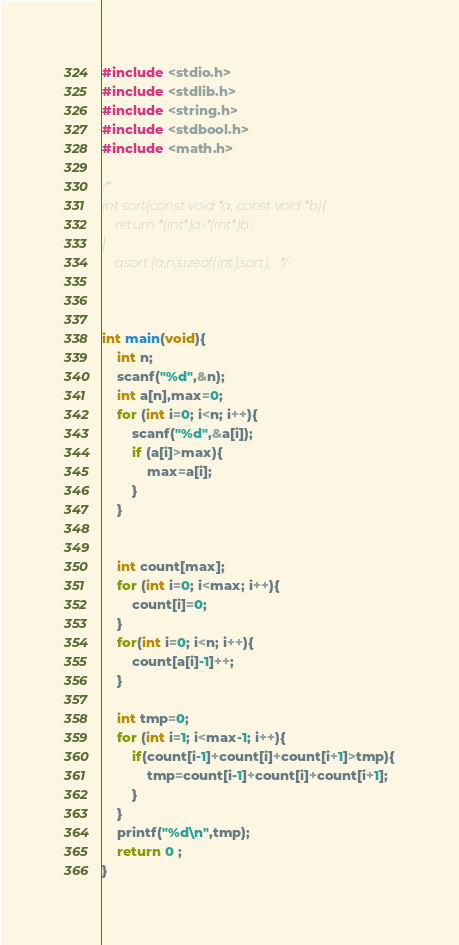<code> <loc_0><loc_0><loc_500><loc_500><_C_>#include <stdio.h>
#include <stdlib.h>
#include <string.h>
#include <stdbool.h>
#include <math.h>

/*
int sort(const void *a, const void *b){
    return *(int*)a-*(int*)b ;
}
    qsort (a,n,sizeof(int),sort);   */



int main(void){
    int n;
    scanf("%d",&n);
    int a[n],max=0;
    for (int i=0; i<n; i++){
        scanf("%d",&a[i]);
        if (a[i]>max){
            max=a[i];
        }
    }

    
    int count[max];
    for (int i=0; i<max; i++){
        count[i]=0;
    }
    for(int i=0; i<n; i++){
        count[a[i]-1]++;
    }
     
    int tmp=0;
    for (int i=1; i<max-1; i++){
        if(count[i-1]+count[i]+count[i+1]>tmp){
            tmp=count[i-1]+count[i]+count[i+1];
        }
    }
    printf("%d\n",tmp);
	return 0 ;
}</code> 